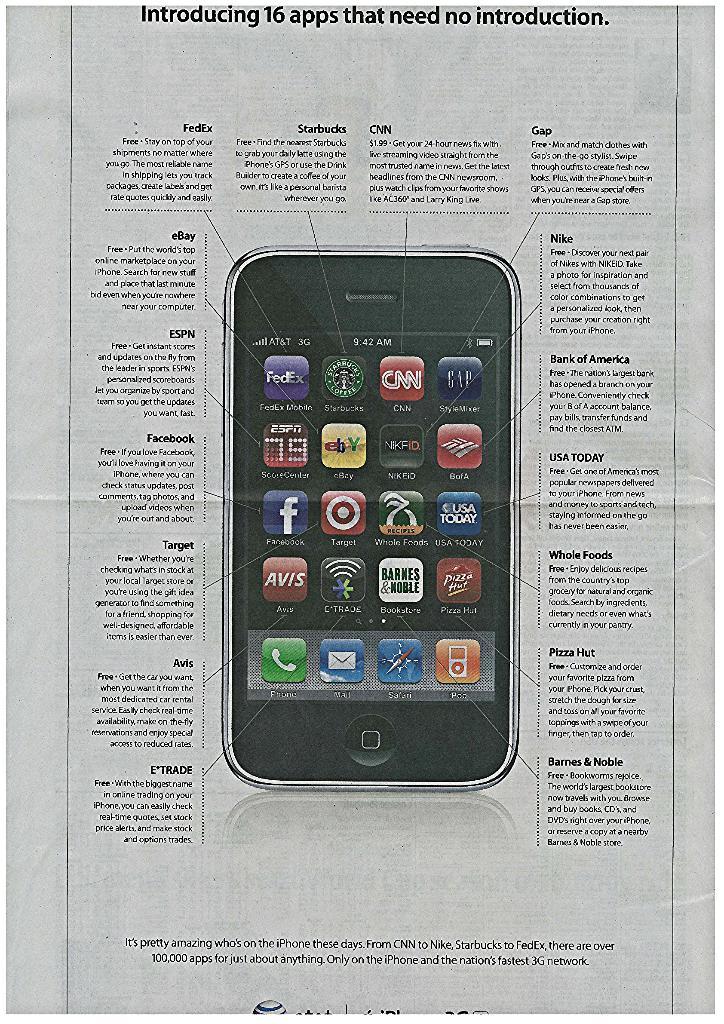How many apps are being showcased on this page?
Make the answer very short. 16. What are some major brands seen on this page?
Ensure brevity in your answer.  Fedex, starbucks, cnn, gap, espn, ebay, nike, bank of america, facebook, target, wholefoods, usa today, avis, etrade, barnes & noble, and pizzahut. 